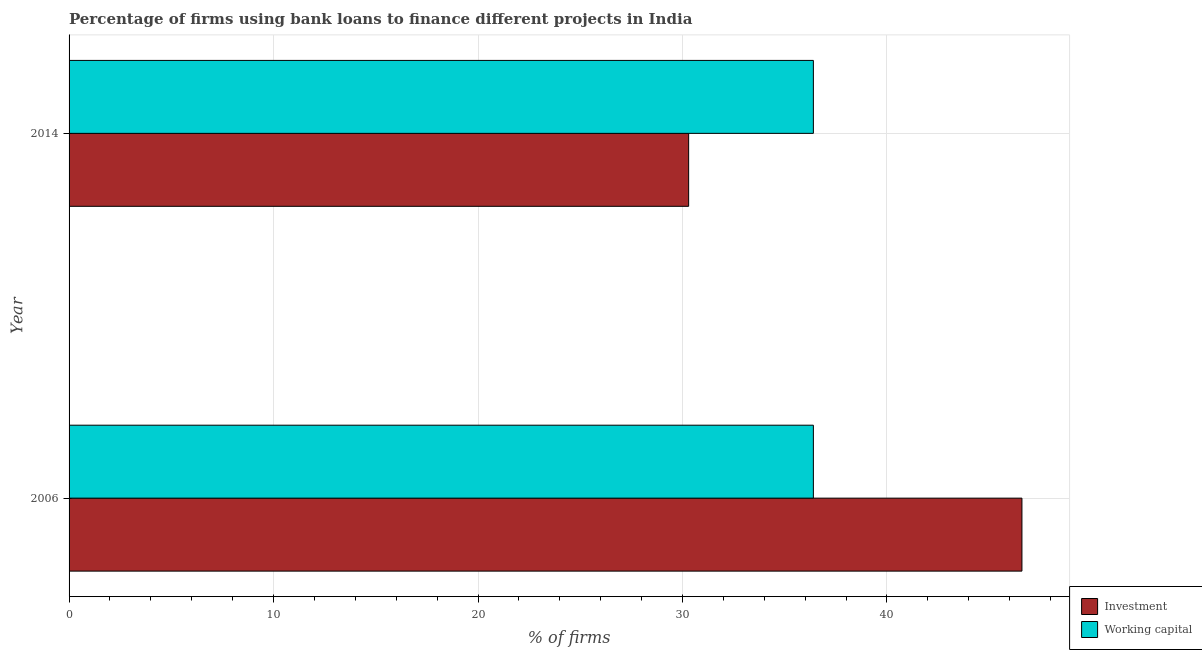How many different coloured bars are there?
Provide a short and direct response. 2. How many groups of bars are there?
Keep it short and to the point. 2. Are the number of bars on each tick of the Y-axis equal?
Keep it short and to the point. Yes. How many bars are there on the 1st tick from the top?
Give a very brief answer. 2. In how many cases, is the number of bars for a given year not equal to the number of legend labels?
Offer a terse response. 0. What is the percentage of firms using banks to finance investment in 2014?
Offer a terse response. 30.3. Across all years, what is the maximum percentage of firms using banks to finance working capital?
Offer a very short reply. 36.4. Across all years, what is the minimum percentage of firms using banks to finance working capital?
Give a very brief answer. 36.4. In which year was the percentage of firms using banks to finance investment minimum?
Offer a very short reply. 2014. What is the total percentage of firms using banks to finance working capital in the graph?
Your response must be concise. 72.8. What is the difference between the percentage of firms using banks to finance working capital in 2006 and that in 2014?
Offer a very short reply. 0. What is the difference between the percentage of firms using banks to finance investment in 2006 and the percentage of firms using banks to finance working capital in 2014?
Keep it short and to the point. 10.2. What is the average percentage of firms using banks to finance investment per year?
Your answer should be very brief. 38.45. In the year 2006, what is the difference between the percentage of firms using banks to finance investment and percentage of firms using banks to finance working capital?
Your answer should be compact. 10.2. In how many years, is the percentage of firms using banks to finance working capital greater than 22 %?
Provide a short and direct response. 2. Is the percentage of firms using banks to finance investment in 2006 less than that in 2014?
Offer a very short reply. No. What does the 2nd bar from the top in 2014 represents?
Keep it short and to the point. Investment. What does the 1st bar from the bottom in 2006 represents?
Offer a very short reply. Investment. Are all the bars in the graph horizontal?
Offer a terse response. Yes. How many years are there in the graph?
Offer a very short reply. 2. Does the graph contain grids?
Keep it short and to the point. Yes. Where does the legend appear in the graph?
Ensure brevity in your answer.  Bottom right. How many legend labels are there?
Offer a terse response. 2. How are the legend labels stacked?
Offer a terse response. Vertical. What is the title of the graph?
Provide a short and direct response. Percentage of firms using bank loans to finance different projects in India. What is the label or title of the X-axis?
Your response must be concise. % of firms. What is the label or title of the Y-axis?
Provide a succinct answer. Year. What is the % of firms in Investment in 2006?
Ensure brevity in your answer.  46.6. What is the % of firms of Working capital in 2006?
Provide a short and direct response. 36.4. What is the % of firms in Investment in 2014?
Offer a very short reply. 30.3. What is the % of firms in Working capital in 2014?
Your response must be concise. 36.4. Across all years, what is the maximum % of firms in Investment?
Your answer should be very brief. 46.6. Across all years, what is the maximum % of firms in Working capital?
Offer a terse response. 36.4. Across all years, what is the minimum % of firms in Investment?
Offer a terse response. 30.3. Across all years, what is the minimum % of firms of Working capital?
Your response must be concise. 36.4. What is the total % of firms of Investment in the graph?
Make the answer very short. 76.9. What is the total % of firms of Working capital in the graph?
Offer a very short reply. 72.8. What is the difference between the % of firms in Investment in 2006 and that in 2014?
Your answer should be compact. 16.3. What is the difference between the % of firms in Working capital in 2006 and that in 2014?
Provide a short and direct response. 0. What is the difference between the % of firms in Investment in 2006 and the % of firms in Working capital in 2014?
Give a very brief answer. 10.2. What is the average % of firms of Investment per year?
Provide a short and direct response. 38.45. What is the average % of firms in Working capital per year?
Provide a short and direct response. 36.4. In the year 2006, what is the difference between the % of firms in Investment and % of firms in Working capital?
Your answer should be very brief. 10.2. What is the ratio of the % of firms of Investment in 2006 to that in 2014?
Offer a terse response. 1.54. What is the ratio of the % of firms in Working capital in 2006 to that in 2014?
Keep it short and to the point. 1. What is the difference between the highest and the second highest % of firms in Working capital?
Your response must be concise. 0. What is the difference between the highest and the lowest % of firms of Investment?
Ensure brevity in your answer.  16.3. 